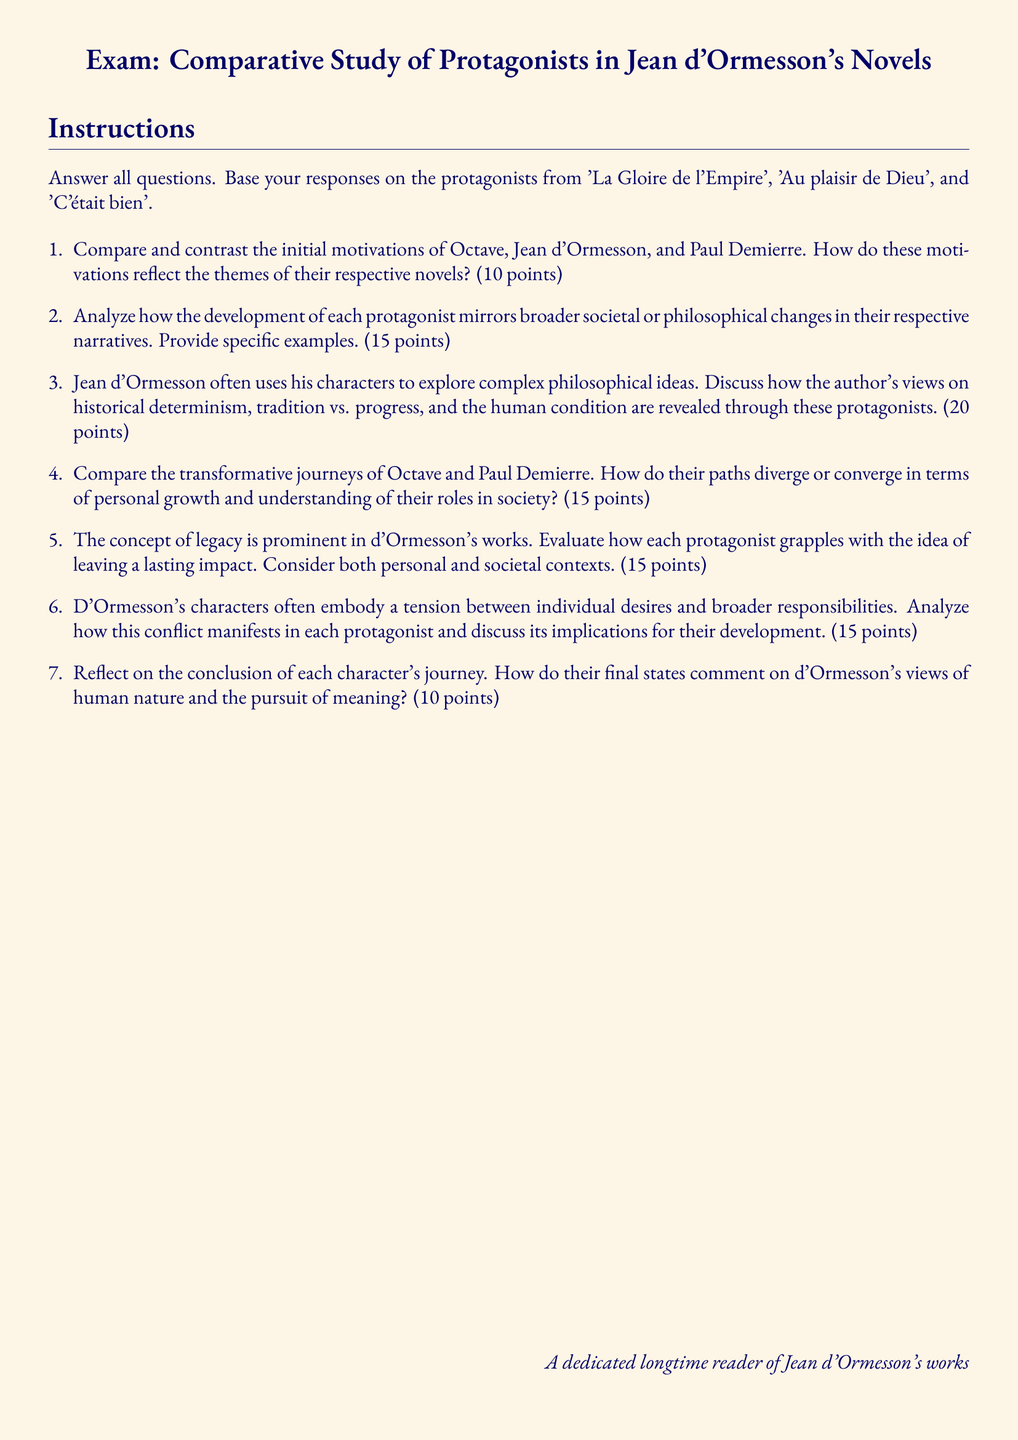What are the main works referenced in the exam? The exam references three major works: 'La Gloire de l'Empire', 'Au plaisir de Dieu', and 'C'était bien'.
Answer: 'La Gloire de l'Empire', 'Au plaisir de Dieu', 'C'était bien' How many points is the question about the initial motivations of the protagonists worth? The question about the initial motivations of the protagonists is assigned a total of 10 points.
Answer: 10 points What is the total number of questions in the exam? The document contains a total of seven questions listed under the enumerated section.
Answer: 7 Which philosophical themes does the exam suggest are explored through the protagonists? The philosophical themes include historical determinism, tradition vs. progress, and the human condition as explored through the protagonists.
Answer: Historical determinism, tradition vs. progress, human condition What is required from the students in the instructions section of the exam? Students are instructed to answer all questions based on the protagonists from the specified three novels.
Answer: Answer all questions In what format should the answers to the exam questions be? The answers should be in short-answer format based on the themes and characters of the novels.
Answer: Short-answer format What is the focus of the second question in the exam? The second question focuses on analyzing the development of each protagonist in relation to societal or philosophical changes.
Answer: Development of each protagonist What type of conflict is highlighted in the protagonists of d'Ormesson's works according to the sixth question? The sixth question highlights the tension between individual desires and broader responsibilities in the lives of the protagonists.
Answer: Individual desires and broader responsibilities 